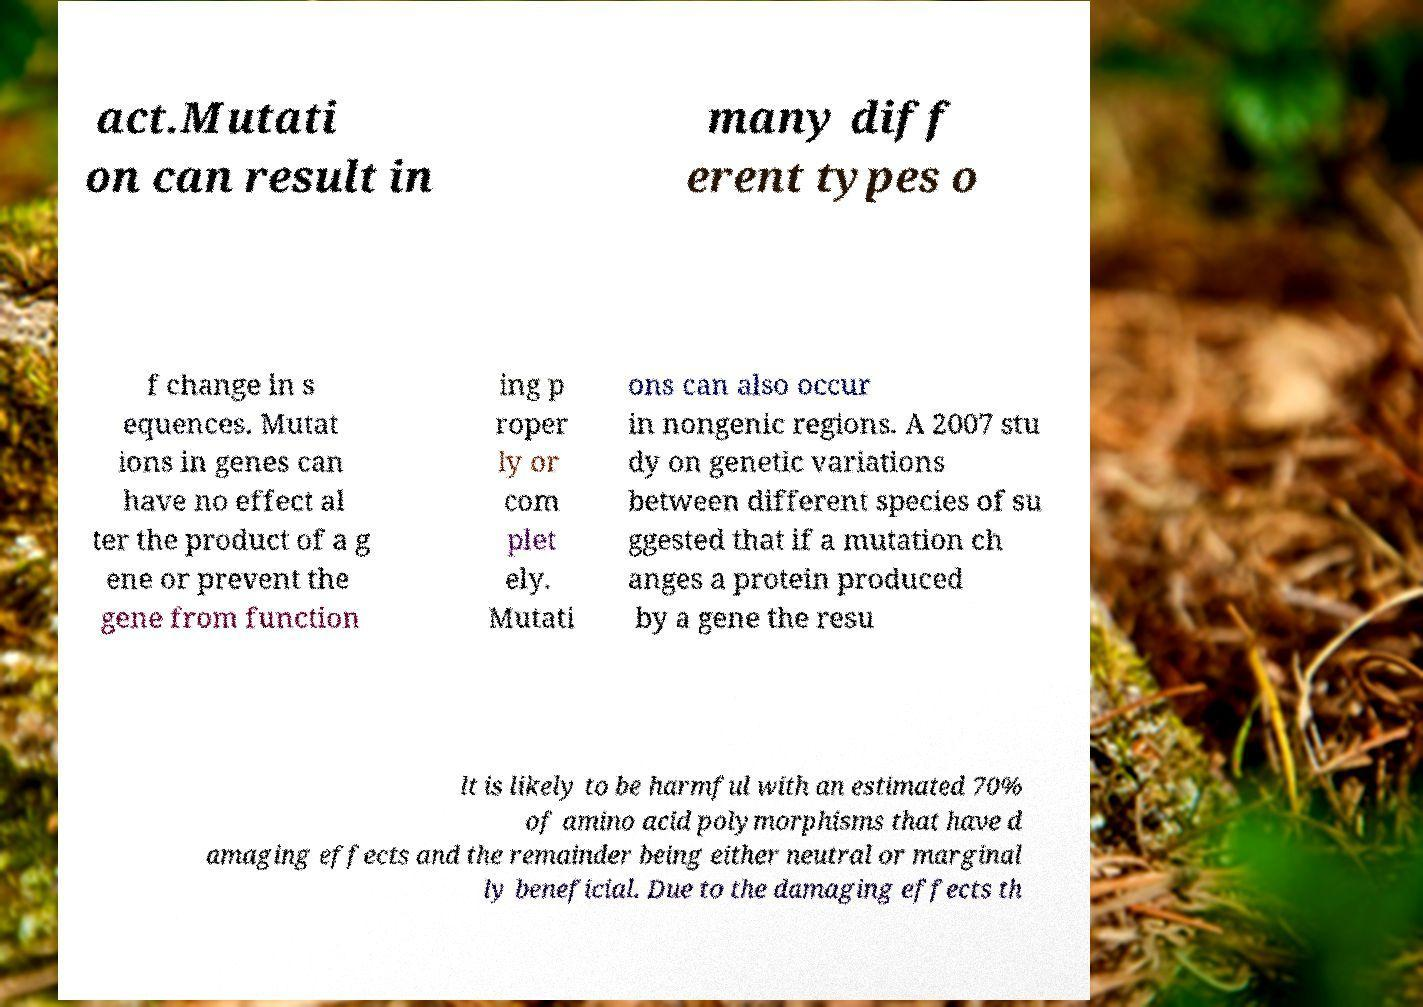Can you read and provide the text displayed in the image?This photo seems to have some interesting text. Can you extract and type it out for me? act.Mutati on can result in many diff erent types o f change in s equences. Mutat ions in genes can have no effect al ter the product of a g ene or prevent the gene from function ing p roper ly or com plet ely. Mutati ons can also occur in nongenic regions. A 2007 stu dy on genetic variations between different species of su ggested that if a mutation ch anges a protein produced by a gene the resu lt is likely to be harmful with an estimated 70% of amino acid polymorphisms that have d amaging effects and the remainder being either neutral or marginal ly beneficial. Due to the damaging effects th 